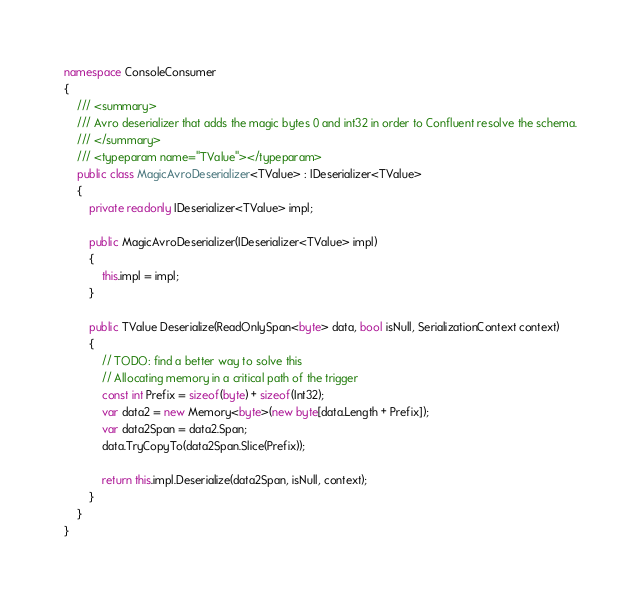<code> <loc_0><loc_0><loc_500><loc_500><_C#_>namespace ConsoleConsumer
{
    /// <summary>
    /// Avro deserializer that adds the magic bytes 0 and int32 in order to Confluent resolve the schema.
    /// </summary>
    /// <typeparam name="TValue"></typeparam>
    public class MagicAvroDeserializer<TValue> : IDeserializer<TValue>
    {
        private readonly IDeserializer<TValue> impl;

        public MagicAvroDeserializer(IDeserializer<TValue> impl)
        {
            this.impl = impl;
        }

        public TValue Deserialize(ReadOnlySpan<byte> data, bool isNull, SerializationContext context)
        {
            // TODO: find a better way to solve this
            // Allocating memory in a critical path of the trigger
            const int Prefix = sizeof(byte) + sizeof(Int32);
            var data2 = new Memory<byte>(new byte[data.Length + Prefix]);
            var data2Span = data2.Span;
            data.TryCopyTo(data2Span.Slice(Prefix));

            return this.impl.Deserialize(data2Span, isNull, context);
        }
    }
}
</code> 